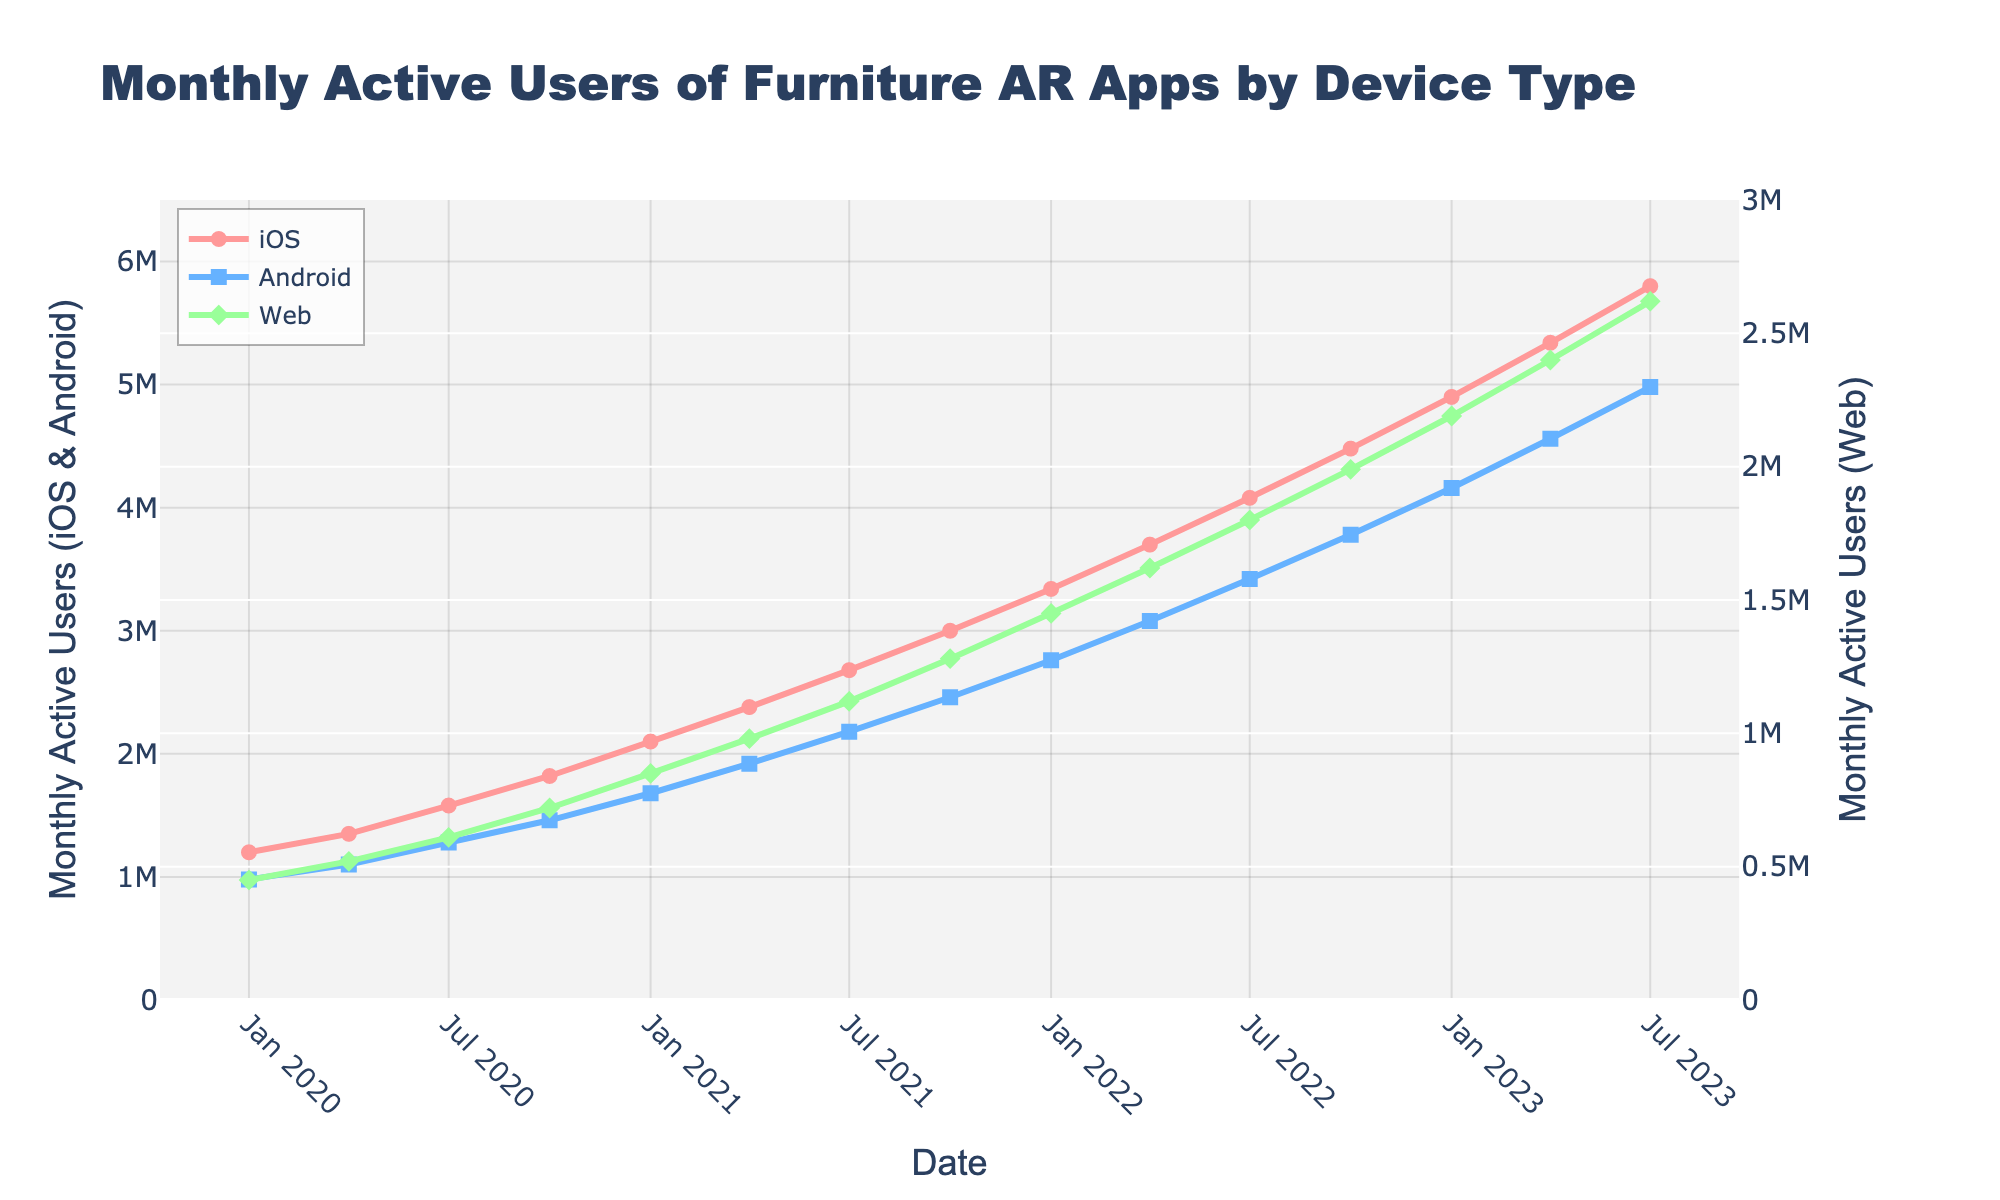When did iOS first surpass 2 million monthly active users? Look at the line representing iOS and find the date at which it first reaches or exceeds 2 million users. This occurs in January 2021.
Answer: January 2021 Which platform had the highest growth in monthly active users between January 2021 and July 2023? Calculate the difference in monthly active users for each platform between January 2021 and July 2023. For iOS: 5800000 - 2100000 = 3700000, for Android: 4980000 - 1680000 = 3300000, for Web: 2620000 - 850000 = 1770000. iOS has the highest growth.
Answer: iOS What is the ratio of iOS users to Web users in October 2022? Divide the number of iOS users by the number of Web users in October 2022. The iOS users are 4480000 and Web users are 1990000, so the ratio is 4480000 / 1990000.
Answer: 2.25 Which platform showed the steadiest growth over the entire period? Observe the lines' slopes representing each platform. iOS, Android, and Web all show a steady increase, but iOS appears to be the most consistent in its upward trajectory without significant dips or plateaus.
Answer: iOS How many more monthly active users did iOS have compared to Android in April 2023? Subtract the number of Android users from the number of iOS users in April 2023. iOS: 5340000, Android: 4560000, the difference is 5340000 - 4560000.
Answer: 780000 What is the approximate average number of Web users from 2020 to mid-2023? Sum the number of Web users at each date and divide by the number of data points (15). Total Web users: 3095000, the average is 3095000 / 15.
Answer: 2060000 Did any platform's monthly active users decrease at any point during the time period? Look for any dips in the lines representing each platform. All three platforms show continual growth without any decreases over the period.
Answer: No What's the percentage increase in Android users from April 2020 to July 2022? Calculate the number of Android users in April 2020 and June 2022, then find the percentage increase. 3420000 - 1100000 = 2320000, percentage increase = (2320000 / 1100000) * 100.
Answer: 210.91% At which point did Web users first reach 1 million? Find the date when the Web users’ line first crosses the 1 million mark. This happens in April 2021.
Answer: April 2021 